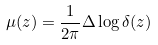<formula> <loc_0><loc_0><loc_500><loc_500>\mu ( z ) = \frac { 1 } { 2 \pi } \Delta \log \delta ( z )</formula> 